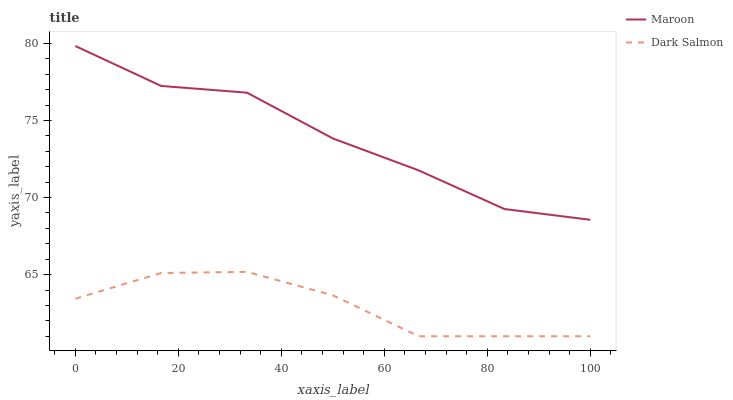Does Dark Salmon have the minimum area under the curve?
Answer yes or no. Yes. Does Maroon have the maximum area under the curve?
Answer yes or no. Yes. Does Maroon have the minimum area under the curve?
Answer yes or no. No. Is Dark Salmon the smoothest?
Answer yes or no. Yes. Is Maroon the roughest?
Answer yes or no. Yes. Is Maroon the smoothest?
Answer yes or no. No. Does Dark Salmon have the lowest value?
Answer yes or no. Yes. Does Maroon have the lowest value?
Answer yes or no. No. Does Maroon have the highest value?
Answer yes or no. Yes. Is Dark Salmon less than Maroon?
Answer yes or no. Yes. Is Maroon greater than Dark Salmon?
Answer yes or no. Yes. Does Dark Salmon intersect Maroon?
Answer yes or no. No. 